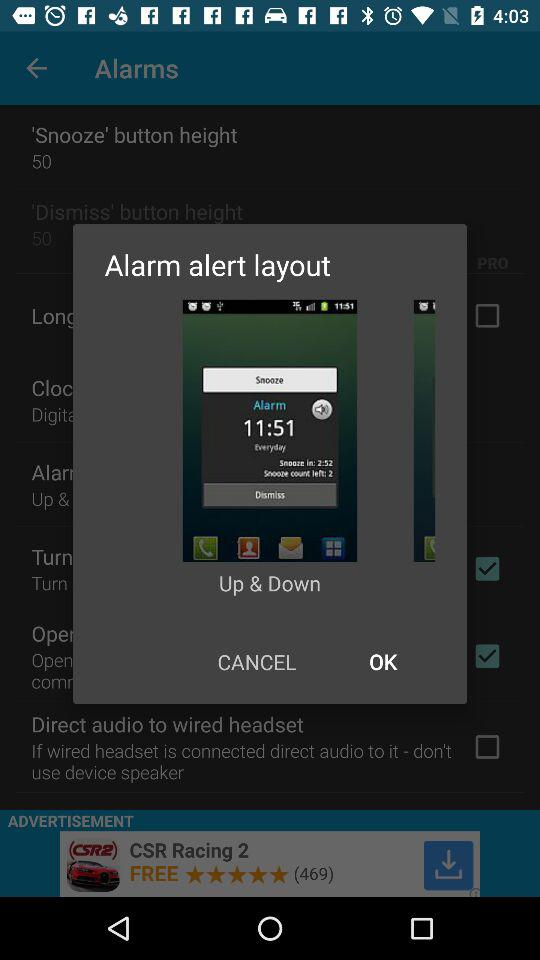What is the name of the shown window? The name of the shown window is "Alarm alert layout". 